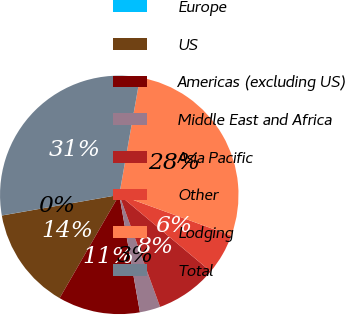Convert chart to OTSL. <chart><loc_0><loc_0><loc_500><loc_500><pie_chart><fcel>Europe<fcel>US<fcel>Americas (excluding US)<fcel>Middle East and Africa<fcel>Asia Pacific<fcel>Other<fcel>Lodging<fcel>Total<nl><fcel>0.01%<fcel>13.89%<fcel>11.11%<fcel>2.79%<fcel>8.34%<fcel>5.56%<fcel>27.76%<fcel>30.54%<nl></chart> 